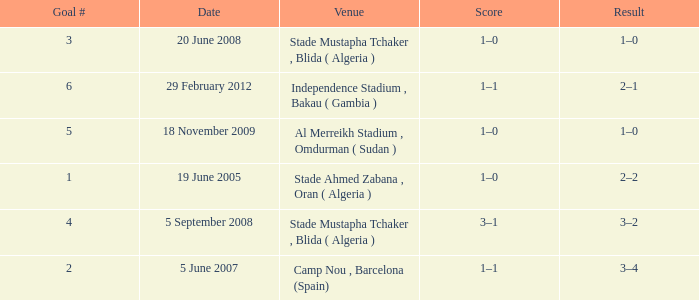What was the venue where goal #2 occured? Camp Nou , Barcelona (Spain). 